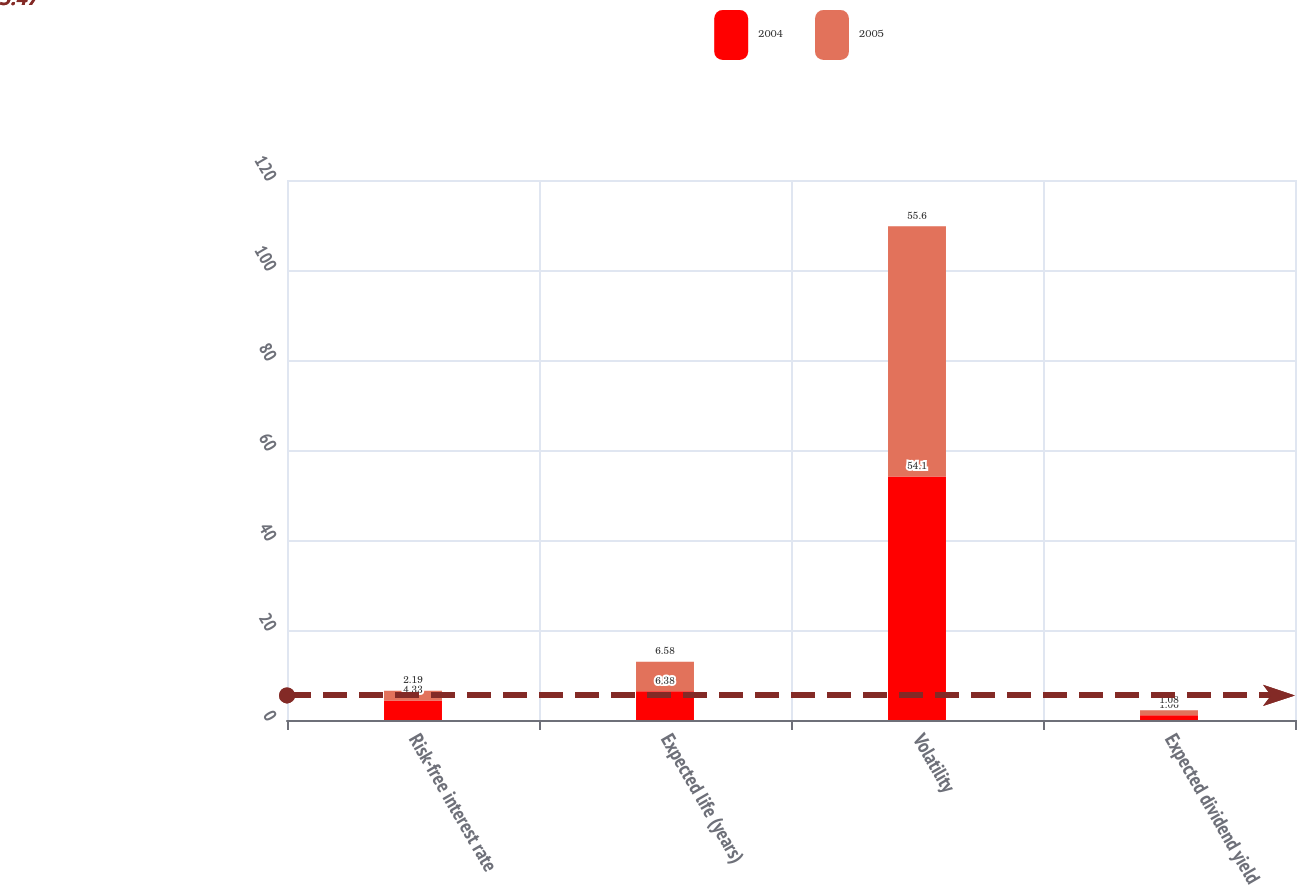Convert chart to OTSL. <chart><loc_0><loc_0><loc_500><loc_500><stacked_bar_chart><ecel><fcel>Risk-free interest rate<fcel>Expected life (years)<fcel>Volatility<fcel>Expected dividend yield<nl><fcel>2004<fcel>4.33<fcel>6.38<fcel>54.1<fcel>1.06<nl><fcel>2005<fcel>2.19<fcel>6.58<fcel>55.6<fcel>1.08<nl></chart> 